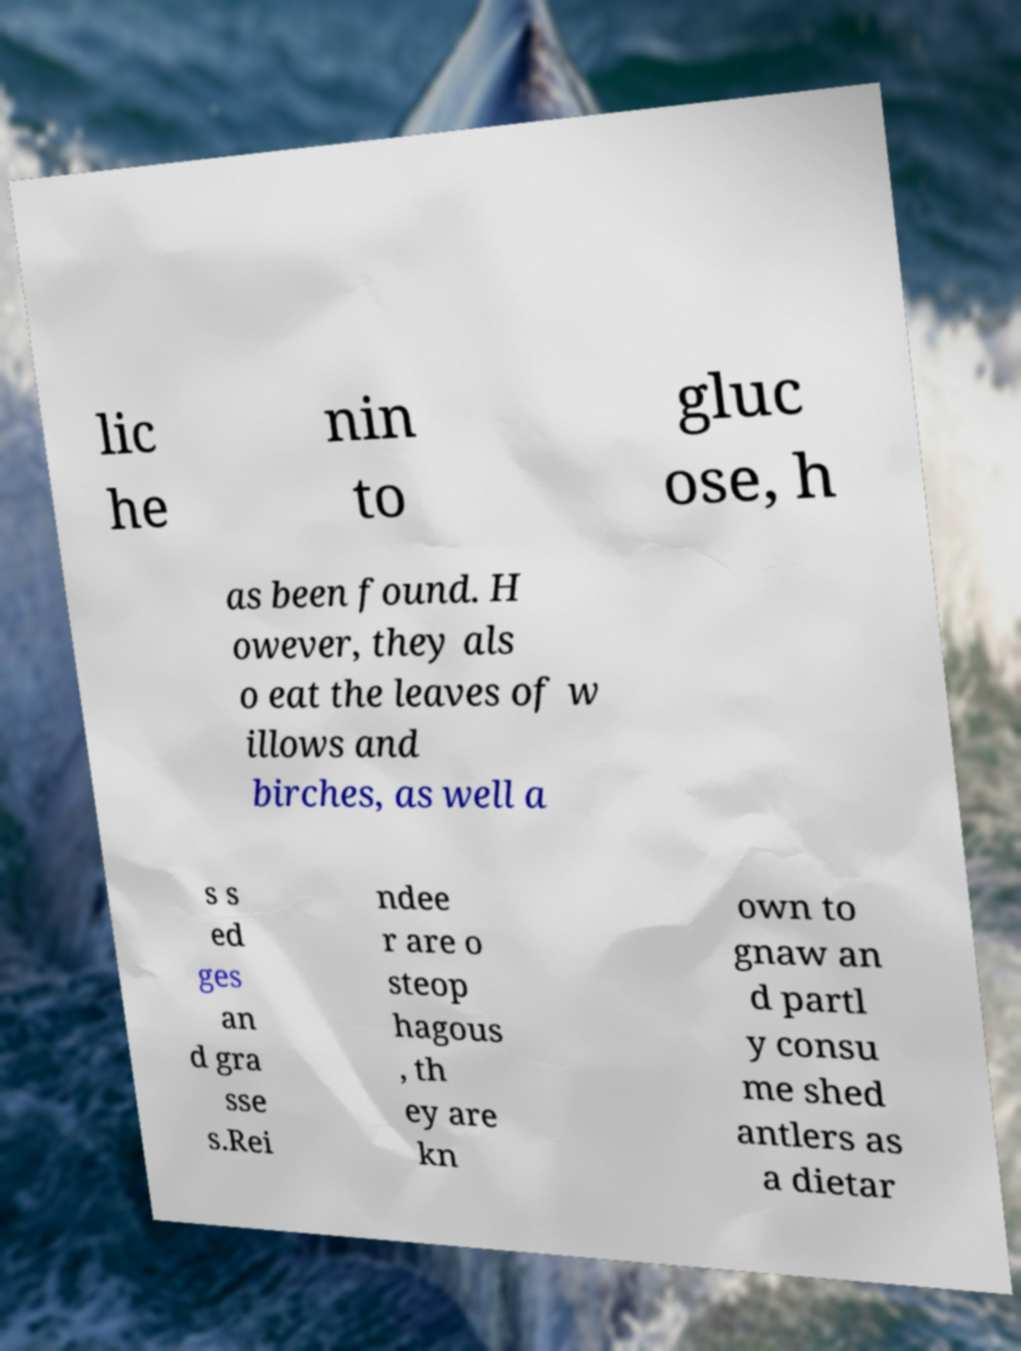Can you read and provide the text displayed in the image?This photo seems to have some interesting text. Can you extract and type it out for me? lic he nin to gluc ose, h as been found. H owever, they als o eat the leaves of w illows and birches, as well a s s ed ges an d gra sse s.Rei ndee r are o steop hagous , th ey are kn own to gnaw an d partl y consu me shed antlers as a dietar 